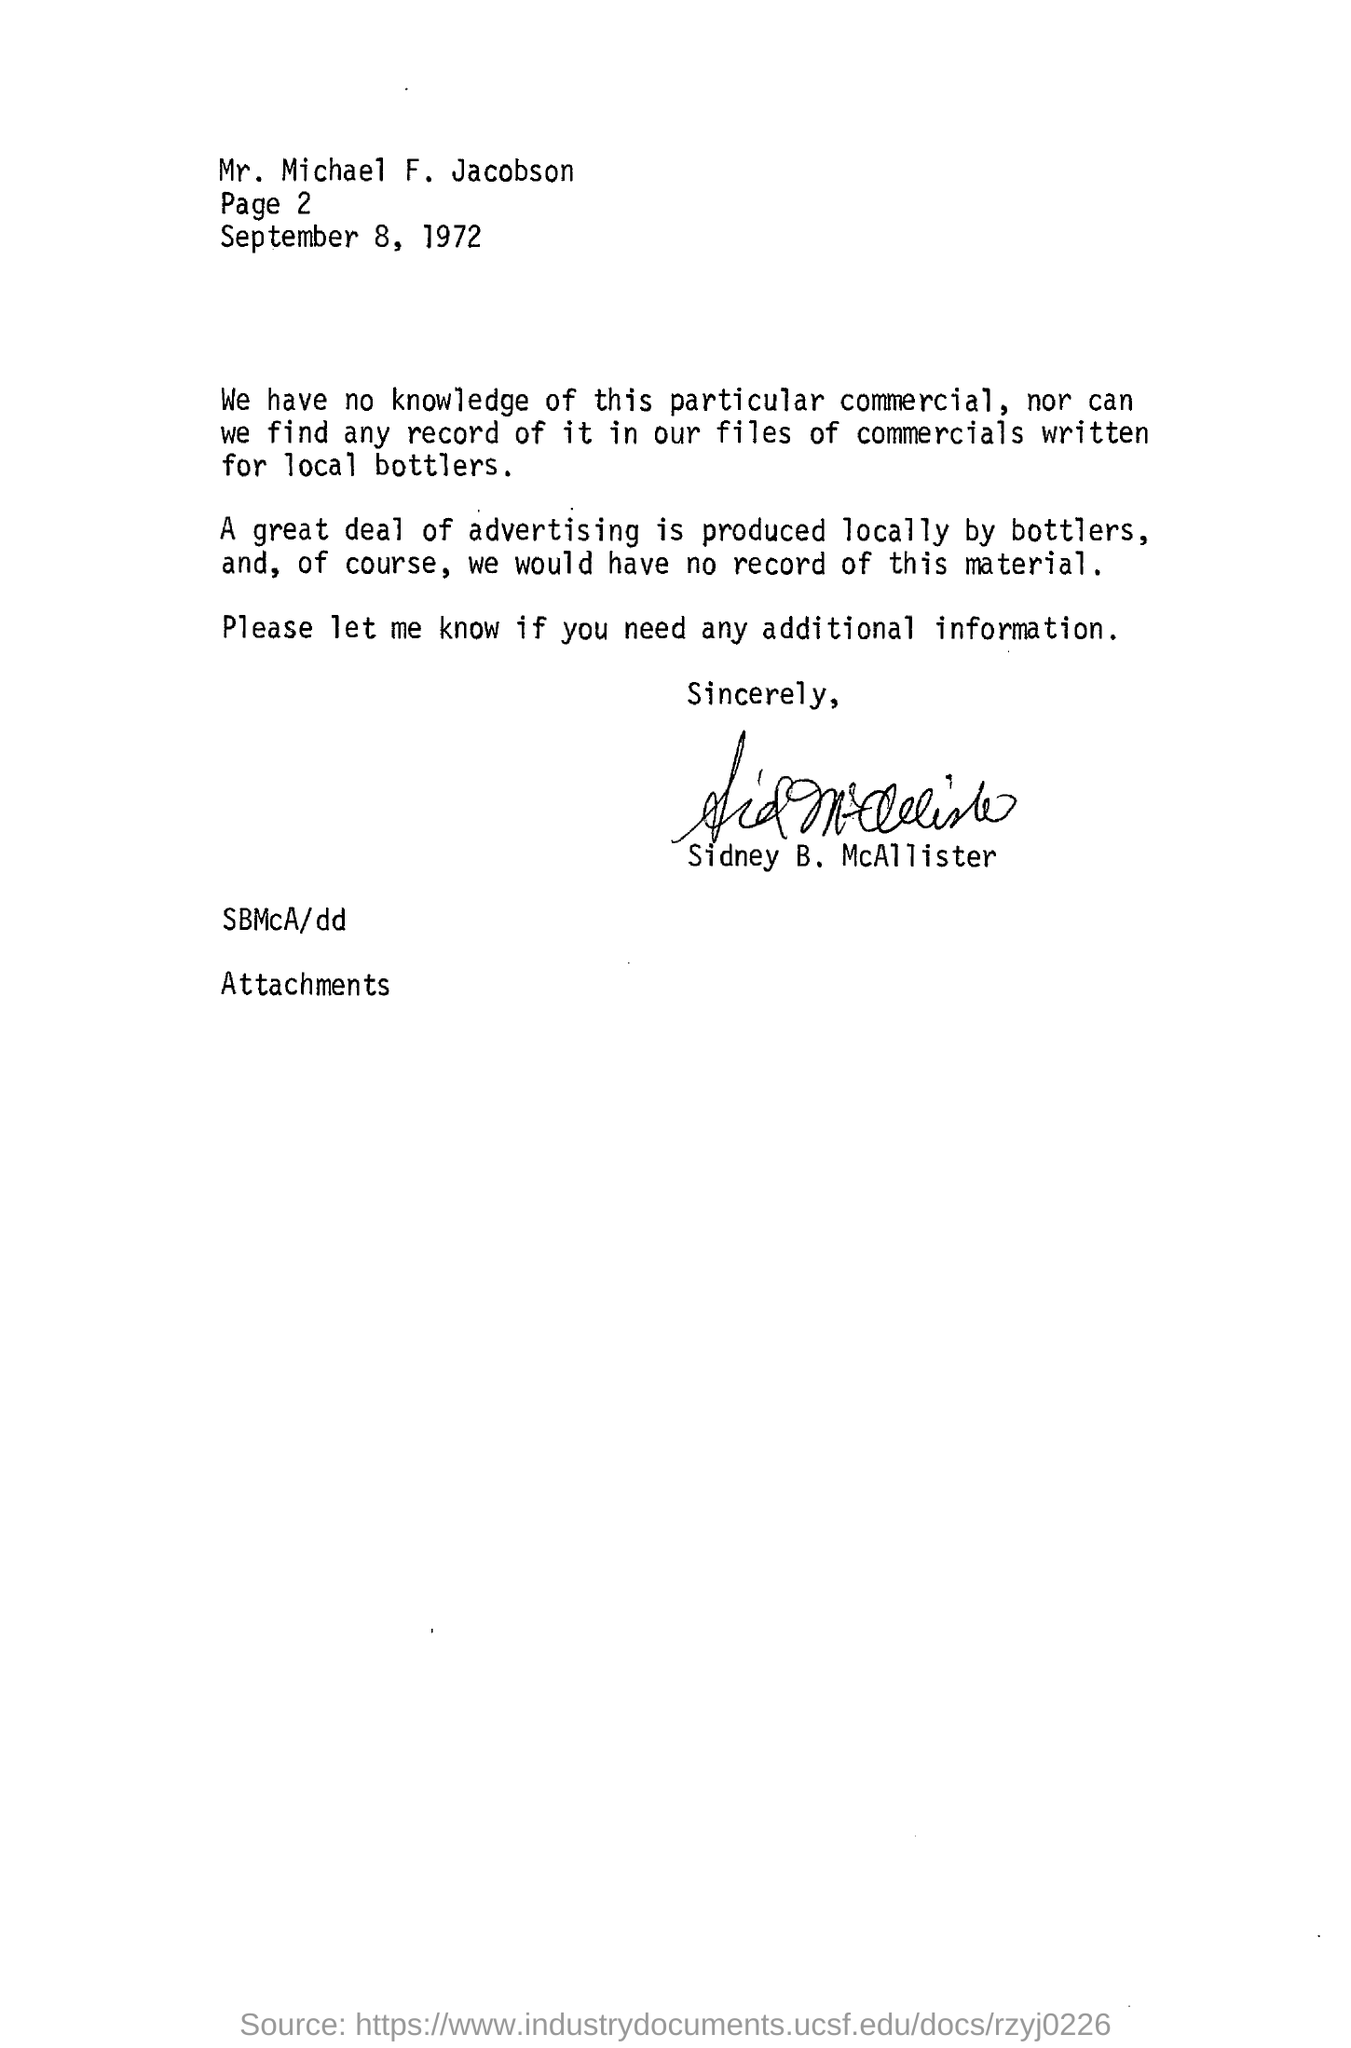Point out several critical features in this image. A significant portion of local advertising is produced by bottlers. 